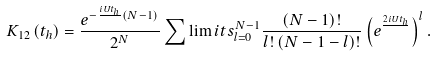<formula> <loc_0><loc_0><loc_500><loc_500>K _ { 1 2 } \left ( t _ { h } \right ) = \frac { e ^ { - \frac { i U t _ { h } } { } \left ( N - 1 \right ) } } { 2 ^ { N } } \sum \lim i t s _ { l = 0 } ^ { N - 1 } \frac { \left ( N - 1 \right ) ! } { l ! \left ( N - 1 - l \right ) ! } \left ( e ^ { \frac { 2 i U t _ { h } } { } } \right ) ^ { l } .</formula> 